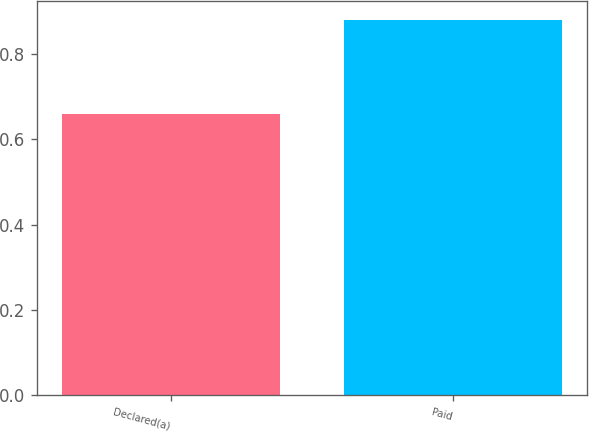Convert chart to OTSL. <chart><loc_0><loc_0><loc_500><loc_500><bar_chart><fcel>Declared(a)<fcel>Paid<nl><fcel>0.66<fcel>0.88<nl></chart> 